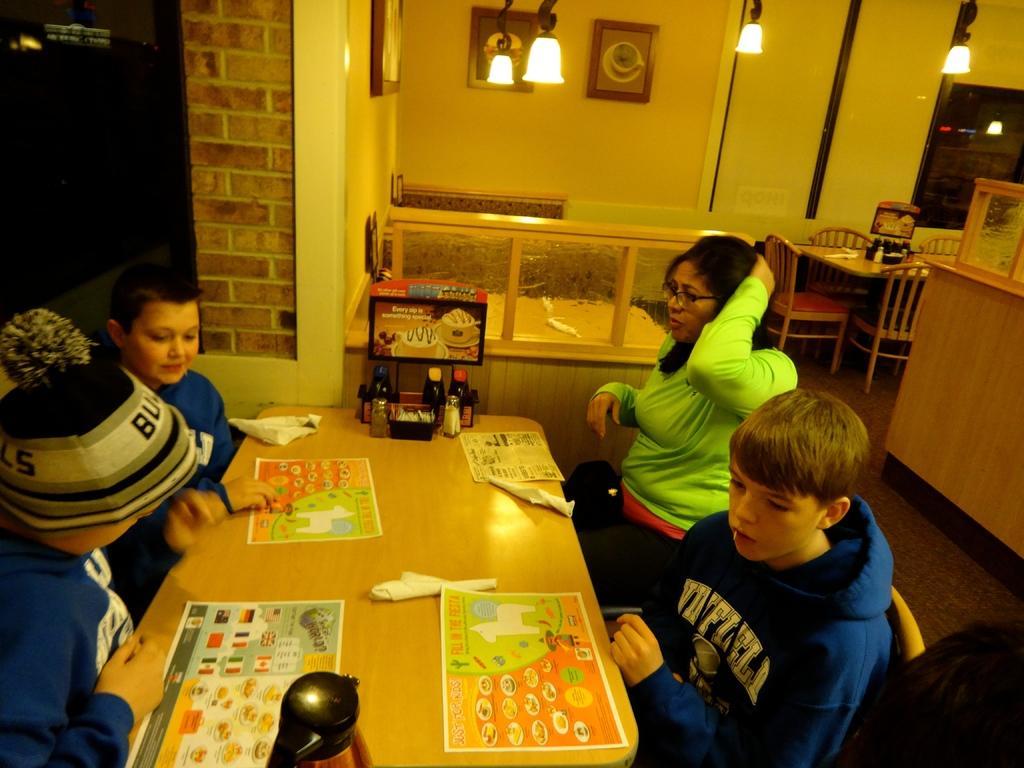Describe this image in one or two sentences. In this picture there are two children who are playing a game. To the right side, there is a boy wearing a blue jacket and is sitting on the chair. There is a woman who is wearing a green jacket and is also sitting on the chair. There is a bottle and a box on the table. There is a light at the roof. on to the right side,there is a chair and a table. 